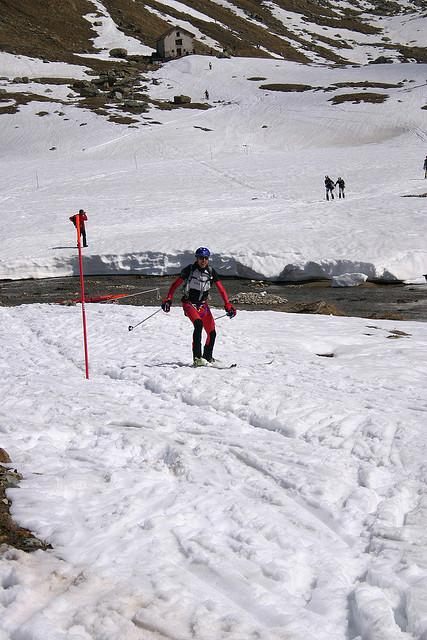What time of day is this? Please explain your reasoning. midday. The sun is directly overhead, casting only small shadows 